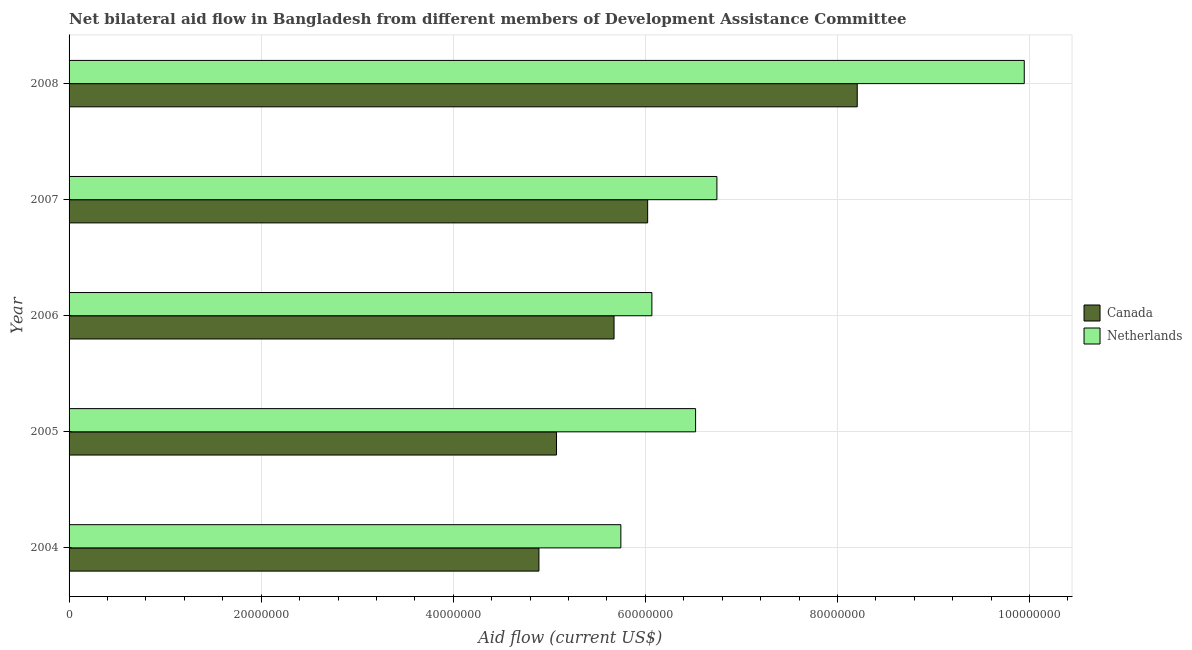How many different coloured bars are there?
Keep it short and to the point. 2. How many groups of bars are there?
Provide a succinct answer. 5. Are the number of bars on each tick of the Y-axis equal?
Your answer should be very brief. Yes. How many bars are there on the 1st tick from the top?
Ensure brevity in your answer.  2. How many bars are there on the 3rd tick from the bottom?
Your answer should be very brief. 2. What is the label of the 2nd group of bars from the top?
Keep it short and to the point. 2007. What is the amount of aid given by netherlands in 2007?
Keep it short and to the point. 6.74e+07. Across all years, what is the maximum amount of aid given by canada?
Offer a terse response. 8.21e+07. Across all years, what is the minimum amount of aid given by netherlands?
Provide a short and direct response. 5.74e+07. What is the total amount of aid given by canada in the graph?
Ensure brevity in your answer.  2.99e+08. What is the difference between the amount of aid given by canada in 2006 and that in 2007?
Offer a terse response. -3.50e+06. What is the difference between the amount of aid given by netherlands in 2008 and the amount of aid given by canada in 2006?
Ensure brevity in your answer.  4.27e+07. What is the average amount of aid given by netherlands per year?
Your answer should be very brief. 7.01e+07. In the year 2006, what is the difference between the amount of aid given by netherlands and amount of aid given by canada?
Make the answer very short. 3.94e+06. What is the ratio of the amount of aid given by canada in 2005 to that in 2006?
Give a very brief answer. 0.89. Is the amount of aid given by netherlands in 2005 less than that in 2008?
Offer a terse response. Yes. Is the difference between the amount of aid given by canada in 2005 and 2007 greater than the difference between the amount of aid given by netherlands in 2005 and 2007?
Offer a terse response. No. What is the difference between the highest and the second highest amount of aid given by canada?
Provide a succinct answer. 2.18e+07. What is the difference between the highest and the lowest amount of aid given by canada?
Offer a very short reply. 3.31e+07. In how many years, is the amount of aid given by canada greater than the average amount of aid given by canada taken over all years?
Offer a very short reply. 2. Is the sum of the amount of aid given by canada in 2006 and 2008 greater than the maximum amount of aid given by netherlands across all years?
Provide a succinct answer. Yes. Are all the bars in the graph horizontal?
Provide a succinct answer. Yes. How many years are there in the graph?
Your response must be concise. 5. What is the difference between two consecutive major ticks on the X-axis?
Your answer should be compact. 2.00e+07. Are the values on the major ticks of X-axis written in scientific E-notation?
Keep it short and to the point. No. Does the graph contain grids?
Give a very brief answer. Yes. Where does the legend appear in the graph?
Keep it short and to the point. Center right. How are the legend labels stacked?
Provide a succinct answer. Vertical. What is the title of the graph?
Provide a succinct answer. Net bilateral aid flow in Bangladesh from different members of Development Assistance Committee. What is the Aid flow (current US$) of Canada in 2004?
Provide a short and direct response. 4.89e+07. What is the Aid flow (current US$) in Netherlands in 2004?
Your answer should be compact. 5.74e+07. What is the Aid flow (current US$) of Canada in 2005?
Provide a short and direct response. 5.08e+07. What is the Aid flow (current US$) of Netherlands in 2005?
Make the answer very short. 6.52e+07. What is the Aid flow (current US$) in Canada in 2006?
Your response must be concise. 5.67e+07. What is the Aid flow (current US$) in Netherlands in 2006?
Give a very brief answer. 6.07e+07. What is the Aid flow (current US$) of Canada in 2007?
Your answer should be compact. 6.02e+07. What is the Aid flow (current US$) of Netherlands in 2007?
Give a very brief answer. 6.74e+07. What is the Aid flow (current US$) of Canada in 2008?
Offer a very short reply. 8.21e+07. What is the Aid flow (current US$) in Netherlands in 2008?
Give a very brief answer. 9.94e+07. Across all years, what is the maximum Aid flow (current US$) of Canada?
Ensure brevity in your answer.  8.21e+07. Across all years, what is the maximum Aid flow (current US$) of Netherlands?
Ensure brevity in your answer.  9.94e+07. Across all years, what is the minimum Aid flow (current US$) in Canada?
Your response must be concise. 4.89e+07. Across all years, what is the minimum Aid flow (current US$) in Netherlands?
Your answer should be very brief. 5.74e+07. What is the total Aid flow (current US$) in Canada in the graph?
Provide a short and direct response. 2.99e+08. What is the total Aid flow (current US$) of Netherlands in the graph?
Your answer should be compact. 3.50e+08. What is the difference between the Aid flow (current US$) of Canada in 2004 and that in 2005?
Keep it short and to the point. -1.83e+06. What is the difference between the Aid flow (current US$) of Netherlands in 2004 and that in 2005?
Your answer should be very brief. -7.78e+06. What is the difference between the Aid flow (current US$) of Canada in 2004 and that in 2006?
Ensure brevity in your answer.  -7.82e+06. What is the difference between the Aid flow (current US$) of Netherlands in 2004 and that in 2006?
Your response must be concise. -3.23e+06. What is the difference between the Aid flow (current US$) of Canada in 2004 and that in 2007?
Keep it short and to the point. -1.13e+07. What is the difference between the Aid flow (current US$) in Netherlands in 2004 and that in 2007?
Make the answer very short. -1.00e+07. What is the difference between the Aid flow (current US$) of Canada in 2004 and that in 2008?
Offer a very short reply. -3.31e+07. What is the difference between the Aid flow (current US$) in Netherlands in 2004 and that in 2008?
Keep it short and to the point. -4.20e+07. What is the difference between the Aid flow (current US$) of Canada in 2005 and that in 2006?
Your answer should be compact. -5.99e+06. What is the difference between the Aid flow (current US$) of Netherlands in 2005 and that in 2006?
Provide a short and direct response. 4.55e+06. What is the difference between the Aid flow (current US$) in Canada in 2005 and that in 2007?
Your answer should be very brief. -9.49e+06. What is the difference between the Aid flow (current US$) in Netherlands in 2005 and that in 2007?
Ensure brevity in your answer.  -2.22e+06. What is the difference between the Aid flow (current US$) of Canada in 2005 and that in 2008?
Your answer should be compact. -3.13e+07. What is the difference between the Aid flow (current US$) of Netherlands in 2005 and that in 2008?
Provide a short and direct response. -3.42e+07. What is the difference between the Aid flow (current US$) in Canada in 2006 and that in 2007?
Keep it short and to the point. -3.50e+06. What is the difference between the Aid flow (current US$) in Netherlands in 2006 and that in 2007?
Offer a terse response. -6.77e+06. What is the difference between the Aid flow (current US$) in Canada in 2006 and that in 2008?
Your answer should be very brief. -2.53e+07. What is the difference between the Aid flow (current US$) of Netherlands in 2006 and that in 2008?
Your response must be concise. -3.88e+07. What is the difference between the Aid flow (current US$) of Canada in 2007 and that in 2008?
Make the answer very short. -2.18e+07. What is the difference between the Aid flow (current US$) in Netherlands in 2007 and that in 2008?
Your answer should be compact. -3.20e+07. What is the difference between the Aid flow (current US$) of Canada in 2004 and the Aid flow (current US$) of Netherlands in 2005?
Give a very brief answer. -1.63e+07. What is the difference between the Aid flow (current US$) in Canada in 2004 and the Aid flow (current US$) in Netherlands in 2006?
Ensure brevity in your answer.  -1.18e+07. What is the difference between the Aid flow (current US$) of Canada in 2004 and the Aid flow (current US$) of Netherlands in 2007?
Your response must be concise. -1.85e+07. What is the difference between the Aid flow (current US$) of Canada in 2004 and the Aid flow (current US$) of Netherlands in 2008?
Ensure brevity in your answer.  -5.05e+07. What is the difference between the Aid flow (current US$) of Canada in 2005 and the Aid flow (current US$) of Netherlands in 2006?
Your response must be concise. -9.93e+06. What is the difference between the Aid flow (current US$) of Canada in 2005 and the Aid flow (current US$) of Netherlands in 2007?
Provide a short and direct response. -1.67e+07. What is the difference between the Aid flow (current US$) in Canada in 2005 and the Aid flow (current US$) in Netherlands in 2008?
Offer a terse response. -4.87e+07. What is the difference between the Aid flow (current US$) in Canada in 2006 and the Aid flow (current US$) in Netherlands in 2007?
Give a very brief answer. -1.07e+07. What is the difference between the Aid flow (current US$) in Canada in 2006 and the Aid flow (current US$) in Netherlands in 2008?
Your answer should be compact. -4.27e+07. What is the difference between the Aid flow (current US$) in Canada in 2007 and the Aid flow (current US$) in Netherlands in 2008?
Offer a very short reply. -3.92e+07. What is the average Aid flow (current US$) of Canada per year?
Offer a very short reply. 5.97e+07. What is the average Aid flow (current US$) in Netherlands per year?
Your response must be concise. 7.01e+07. In the year 2004, what is the difference between the Aid flow (current US$) in Canada and Aid flow (current US$) in Netherlands?
Keep it short and to the point. -8.53e+06. In the year 2005, what is the difference between the Aid flow (current US$) in Canada and Aid flow (current US$) in Netherlands?
Your response must be concise. -1.45e+07. In the year 2006, what is the difference between the Aid flow (current US$) of Canada and Aid flow (current US$) of Netherlands?
Ensure brevity in your answer.  -3.94e+06. In the year 2007, what is the difference between the Aid flow (current US$) of Canada and Aid flow (current US$) of Netherlands?
Your answer should be compact. -7.21e+06. In the year 2008, what is the difference between the Aid flow (current US$) in Canada and Aid flow (current US$) in Netherlands?
Ensure brevity in your answer.  -1.74e+07. What is the ratio of the Aid flow (current US$) in Canada in 2004 to that in 2005?
Offer a very short reply. 0.96. What is the ratio of the Aid flow (current US$) in Netherlands in 2004 to that in 2005?
Ensure brevity in your answer.  0.88. What is the ratio of the Aid flow (current US$) of Canada in 2004 to that in 2006?
Provide a short and direct response. 0.86. What is the ratio of the Aid flow (current US$) in Netherlands in 2004 to that in 2006?
Your answer should be compact. 0.95. What is the ratio of the Aid flow (current US$) of Canada in 2004 to that in 2007?
Your response must be concise. 0.81. What is the ratio of the Aid flow (current US$) in Netherlands in 2004 to that in 2007?
Your answer should be compact. 0.85. What is the ratio of the Aid flow (current US$) of Canada in 2004 to that in 2008?
Make the answer very short. 0.6. What is the ratio of the Aid flow (current US$) of Netherlands in 2004 to that in 2008?
Offer a terse response. 0.58. What is the ratio of the Aid flow (current US$) of Canada in 2005 to that in 2006?
Give a very brief answer. 0.89. What is the ratio of the Aid flow (current US$) of Netherlands in 2005 to that in 2006?
Your answer should be compact. 1.07. What is the ratio of the Aid flow (current US$) in Canada in 2005 to that in 2007?
Make the answer very short. 0.84. What is the ratio of the Aid flow (current US$) of Netherlands in 2005 to that in 2007?
Offer a terse response. 0.97. What is the ratio of the Aid flow (current US$) in Canada in 2005 to that in 2008?
Provide a short and direct response. 0.62. What is the ratio of the Aid flow (current US$) of Netherlands in 2005 to that in 2008?
Give a very brief answer. 0.66. What is the ratio of the Aid flow (current US$) in Canada in 2006 to that in 2007?
Your response must be concise. 0.94. What is the ratio of the Aid flow (current US$) of Netherlands in 2006 to that in 2007?
Give a very brief answer. 0.9. What is the ratio of the Aid flow (current US$) of Canada in 2006 to that in 2008?
Offer a very short reply. 0.69. What is the ratio of the Aid flow (current US$) of Netherlands in 2006 to that in 2008?
Your answer should be compact. 0.61. What is the ratio of the Aid flow (current US$) of Canada in 2007 to that in 2008?
Give a very brief answer. 0.73. What is the ratio of the Aid flow (current US$) in Netherlands in 2007 to that in 2008?
Give a very brief answer. 0.68. What is the difference between the highest and the second highest Aid flow (current US$) in Canada?
Ensure brevity in your answer.  2.18e+07. What is the difference between the highest and the second highest Aid flow (current US$) of Netherlands?
Ensure brevity in your answer.  3.20e+07. What is the difference between the highest and the lowest Aid flow (current US$) in Canada?
Your response must be concise. 3.31e+07. What is the difference between the highest and the lowest Aid flow (current US$) of Netherlands?
Provide a succinct answer. 4.20e+07. 